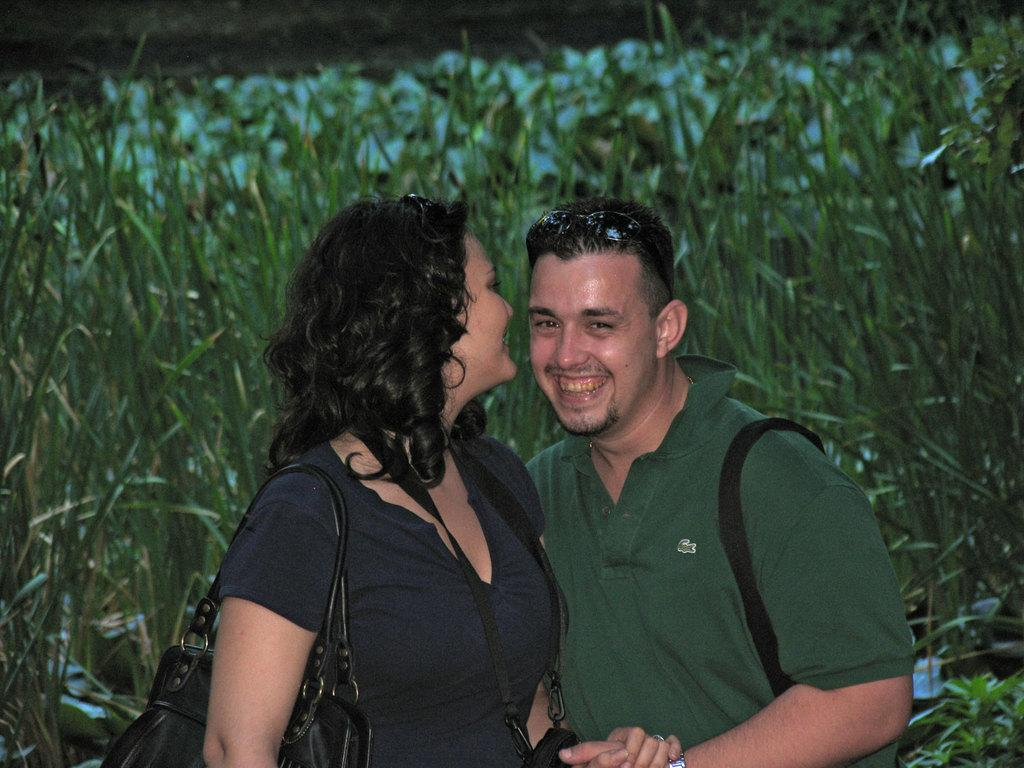Who is present in the image? There is a man and a woman in the image. What are the expressions on their faces? Both the man and the woman are smiling in the image. What can be seen in the background of the image? There are plants and grass in the background of the image. How many beads are on the fold of the woman's dress in the image? There is no mention of beads or a fold in the woman's dress in the image. What type of cakes are being served in the image? There are no cakes present in the image. 